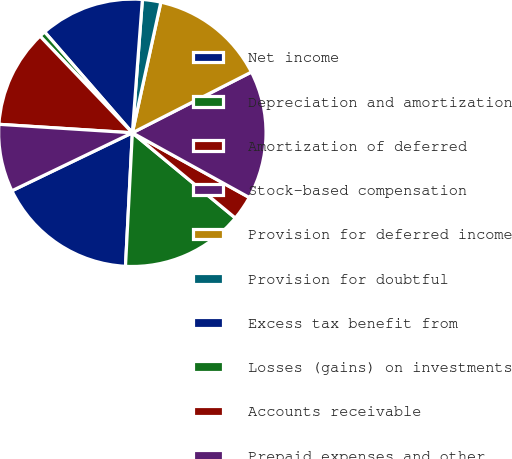Convert chart. <chart><loc_0><loc_0><loc_500><loc_500><pie_chart><fcel>Net income<fcel>Depreciation and amortization<fcel>Amortization of deferred<fcel>Stock-based compensation<fcel>Provision for deferred income<fcel>Provision for doubtful<fcel>Excess tax benefit from<fcel>Losses (gains) on investments<fcel>Accounts receivable<fcel>Prepaid expenses and other<nl><fcel>17.04%<fcel>14.81%<fcel>2.96%<fcel>15.55%<fcel>14.07%<fcel>2.22%<fcel>12.59%<fcel>0.74%<fcel>11.85%<fcel>8.15%<nl></chart> 